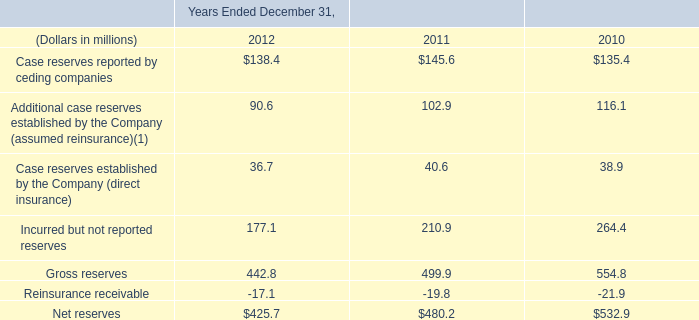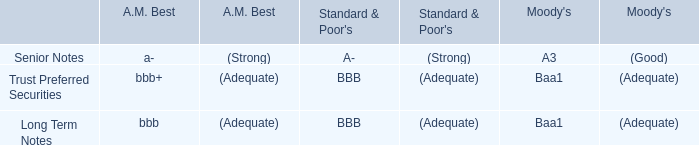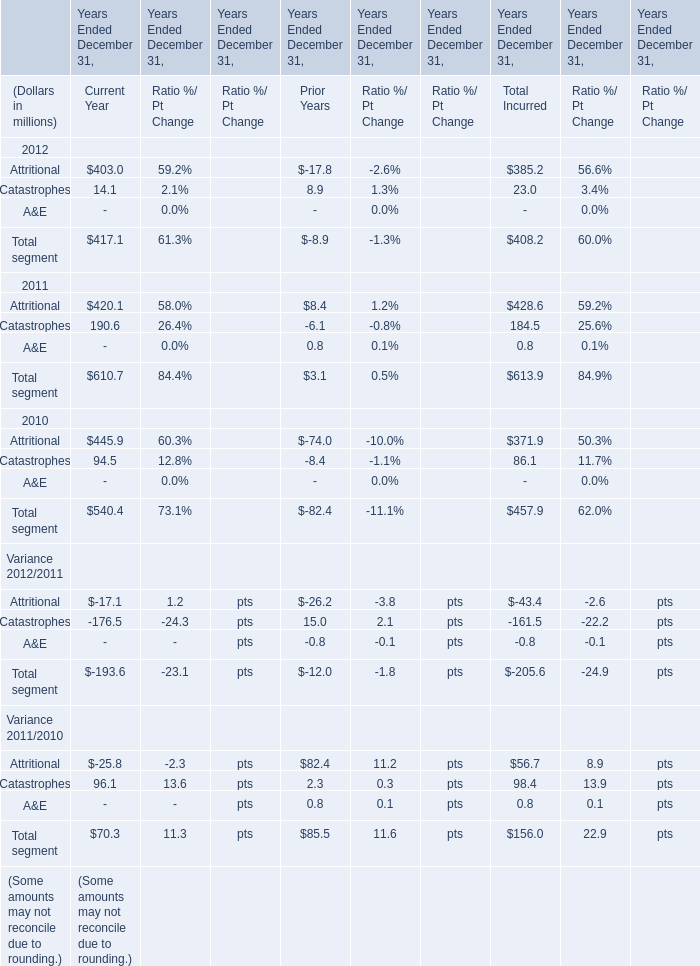In which year is Catastrophes greater than 100 in current year? 
Answer: 2011. 